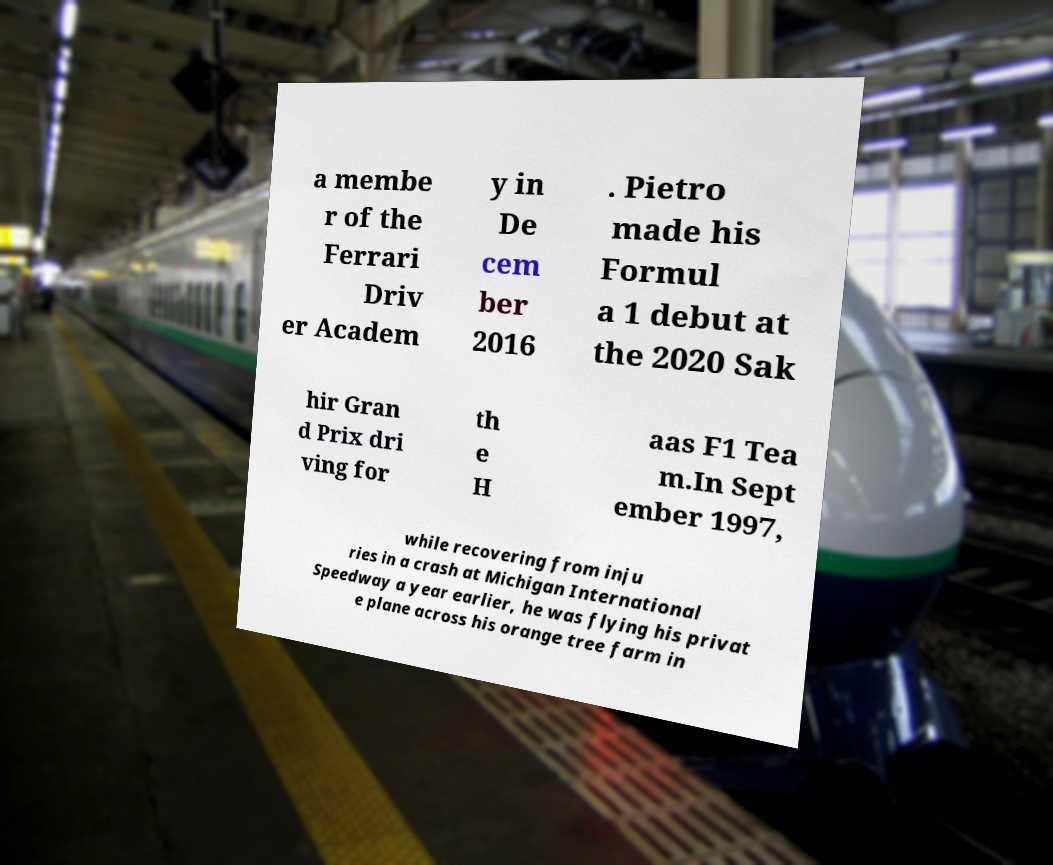Can you read and provide the text displayed in the image?This photo seems to have some interesting text. Can you extract and type it out for me? a membe r of the Ferrari Driv er Academ y in De cem ber 2016 . Pietro made his Formul a 1 debut at the 2020 Sak hir Gran d Prix dri ving for th e H aas F1 Tea m.In Sept ember 1997, while recovering from inju ries in a crash at Michigan International Speedway a year earlier, he was flying his privat e plane across his orange tree farm in 